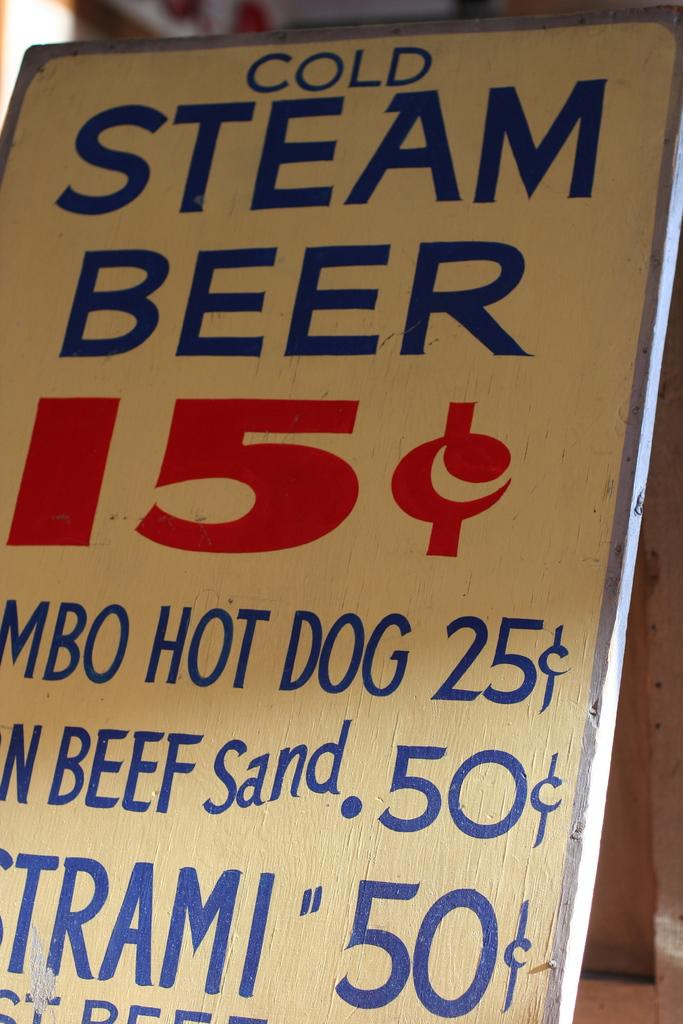<image>
Summarize the visual content of the image. A sign offering Cold Steam Beer for fifteen cents. 